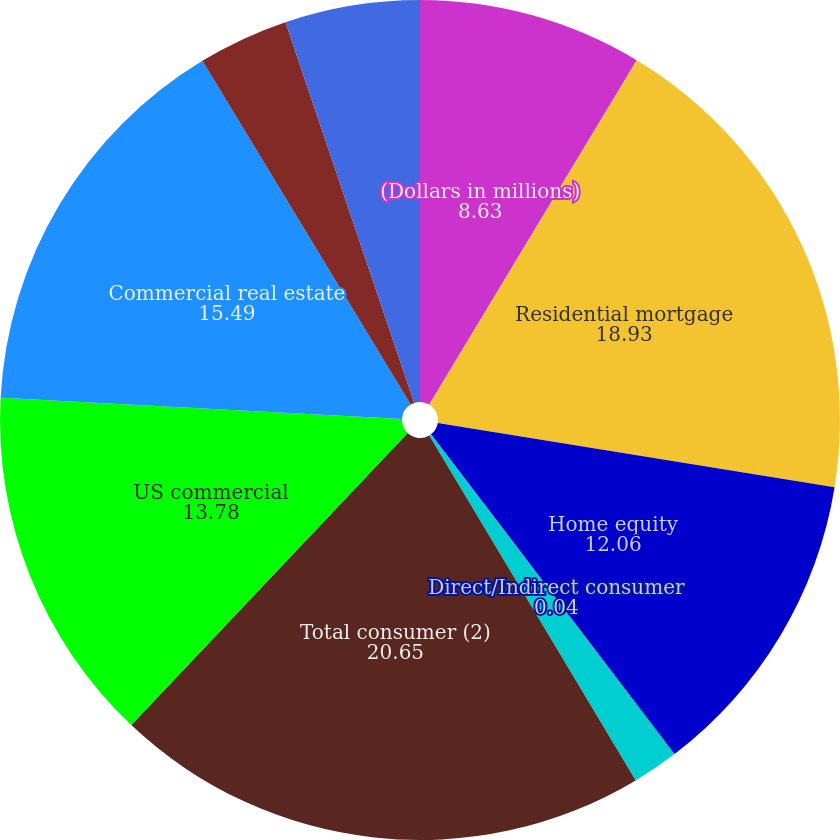<chart> <loc_0><loc_0><loc_500><loc_500><pie_chart><fcel>(Dollars in millions)<fcel>Residential mortgage<fcel>Home equity<fcel>Direct/Indirect consumer<fcel>Other consumer<fcel>Total consumer (2)<fcel>US commercial<fcel>Commercial real estate<fcel>Commercial lease financing<fcel>Non-US commercial<nl><fcel>8.63%<fcel>18.93%<fcel>12.06%<fcel>0.04%<fcel>1.76%<fcel>20.65%<fcel>13.78%<fcel>15.49%<fcel>3.48%<fcel>5.19%<nl></chart> 